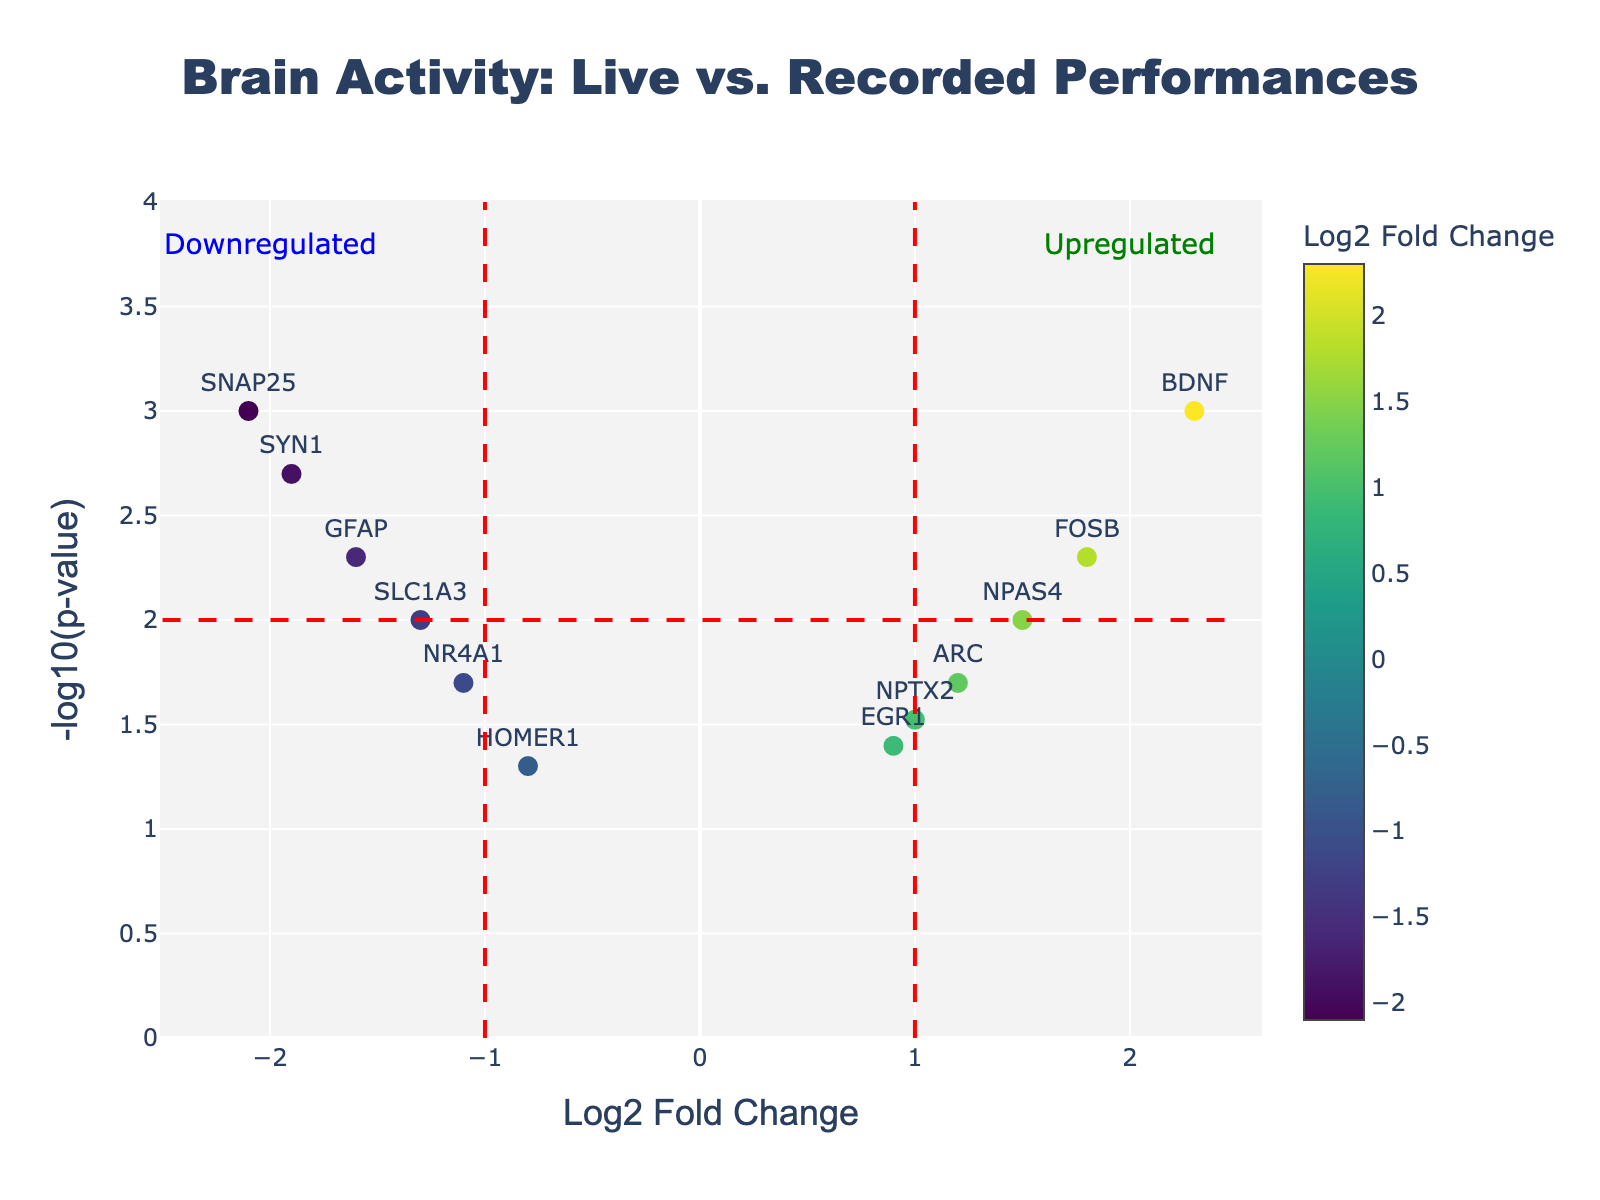How many genes are shown in the plot? Count the number of gene labels displayed on the plot. There are a total of 12 genes: BDNF, FOSB, NPAS4, ARC, NPTX2, EGR1, HOMER1, NR4A1, SLC1A3, GFAP, SYN1, and SNAP25.
Answer: 12 What does the x-axis represent in the plot? The x-axis shows the Log2 Fold Change (Log2FC) of gene expression, which indicates how much the expression of a gene is increased or decreased. A positive value indicates upregulation, and a negative value indicates downregulation.
Answer: Log2 Fold Change Which gene has the highest Log2 Fold Change? Look for the gene label with the highest value on the x-axis. The gene label BDNF corresponds to the highest Log2 Fold Change of 2.3.
Answer: BDNF Are there more upregulated or downregulated genes in this plot? Count the number of genes with positive Log2 Fold Change (upregulated) and negative Log2 Fold Change (downregulated). There are 6 upregulated genes (Log2 Fold Change > 0) and 6 downregulated genes (Log2 Fold Change < 0).
Answer: Equal number of upregulated and downregulated genes What does the y-axis represent in the plot? The y-axis represents the negative logarithm of the p-value (-log10(p-value)), which indicates the statistical significance of the change in gene expression. Higher values represent more statistically significant changes.
Answer: -log10(p-value) Which gene is the most statistically significant? Look for the gene label closest to the top of the plot, which has the highest -log10(p-value). The gene SNAP25 has the highest -log10(p-value), indicating a p-value of 0.001.
Answer: SNAP25 What is the Log2 Fold Change range of the genes in the plot? Identify the minimum and maximum values on the x-axis. The minimum Log2 Fold Change is -2.1 (SNAP25), and the maximum is 2.3 (BDNF). The range is 2.3 - (-2.1) = 4.4.
Answer: 4.4 Which gene has a fold change less than -1 but greater than -2 and is significantly downregulated? Identify the gene with a Log2 Fold Change in the specified range and the highest -log10(p-value) on the plot. The gene SYN1 has a Log2 Fold Change of -1.9 and a p-value of 0.002, which makes it significantly downregulated.
Answer: SYN1 Which gene seems to be the least statistically significant but still shows some upregulation? Look for the gene with the lowest -log10(p-value) on the plot that has a positive Log2 Fold Change. The gene HOMER1 has a Log2 Fold Change of -0.8 and a p-value of 0.05, making it slightly upregulated.
Answer: HOMER1 